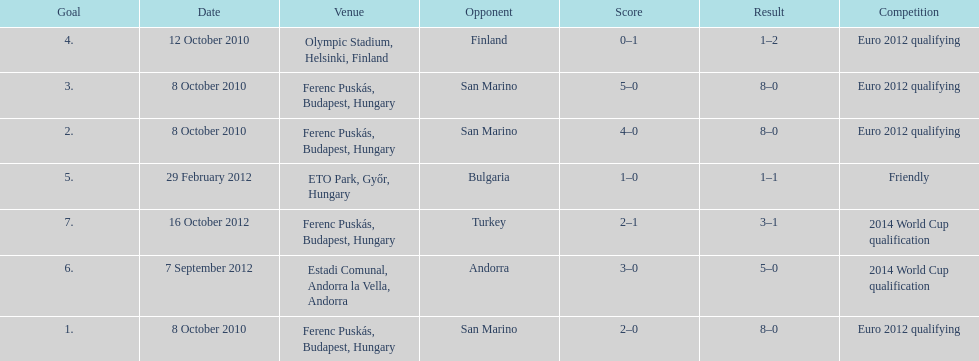In what year did ádám szalai make his next international goal after 2010? 2012. 